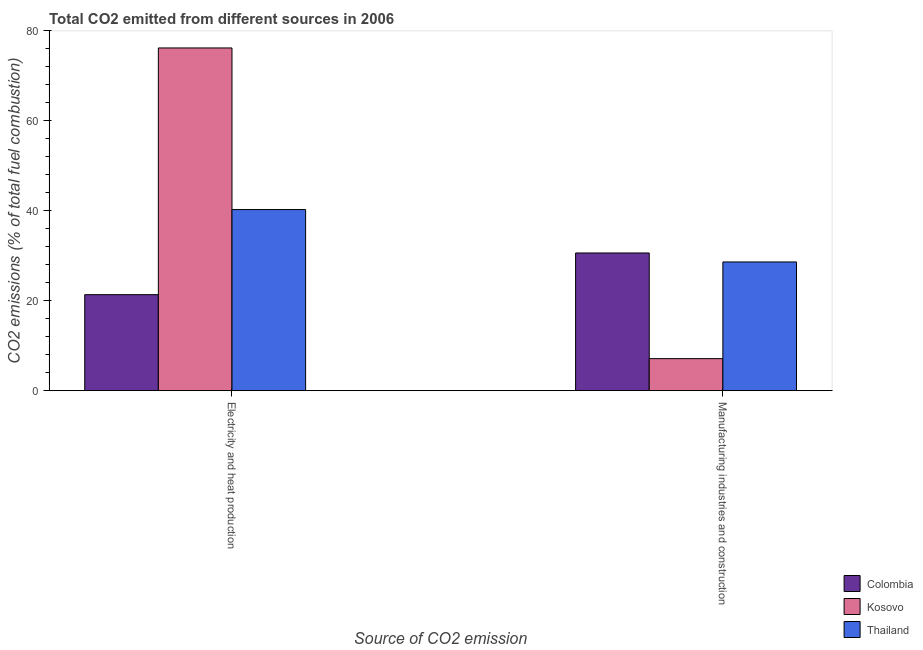How many different coloured bars are there?
Make the answer very short. 3. How many groups of bars are there?
Your answer should be very brief. 2. Are the number of bars per tick equal to the number of legend labels?
Make the answer very short. Yes. How many bars are there on the 2nd tick from the left?
Your answer should be compact. 3. How many bars are there on the 1st tick from the right?
Give a very brief answer. 3. What is the label of the 1st group of bars from the left?
Make the answer very short. Electricity and heat production. What is the co2 emissions due to manufacturing industries in Kosovo?
Your answer should be very brief. 7.12. Across all countries, what is the maximum co2 emissions due to manufacturing industries?
Offer a very short reply. 30.62. Across all countries, what is the minimum co2 emissions due to electricity and heat production?
Provide a succinct answer. 21.35. In which country was the co2 emissions due to electricity and heat production minimum?
Your answer should be compact. Colombia. What is the total co2 emissions due to manufacturing industries in the graph?
Make the answer very short. 66.35. What is the difference between the co2 emissions due to manufacturing industries in Colombia and that in Thailand?
Give a very brief answer. 2. What is the difference between the co2 emissions due to electricity and heat production in Colombia and the co2 emissions due to manufacturing industries in Kosovo?
Your response must be concise. 14.22. What is the average co2 emissions due to manufacturing industries per country?
Provide a short and direct response. 22.12. What is the difference between the co2 emissions due to manufacturing industries and co2 emissions due to electricity and heat production in Colombia?
Your answer should be compact. 9.27. In how many countries, is the co2 emissions due to electricity and heat production greater than 20 %?
Offer a very short reply. 3. What is the ratio of the co2 emissions due to electricity and heat production in Thailand to that in Colombia?
Make the answer very short. 1.89. Is the co2 emissions due to manufacturing industries in Kosovo less than that in Colombia?
Make the answer very short. Yes. What does the 2nd bar from the left in Electricity and heat production represents?
Provide a short and direct response. Kosovo. What does the 3rd bar from the right in Electricity and heat production represents?
Give a very brief answer. Colombia. What is the difference between two consecutive major ticks on the Y-axis?
Your answer should be very brief. 20. Are the values on the major ticks of Y-axis written in scientific E-notation?
Offer a terse response. No. Does the graph contain any zero values?
Offer a very short reply. No. Does the graph contain grids?
Your response must be concise. No. Where does the legend appear in the graph?
Ensure brevity in your answer.  Bottom right. How are the legend labels stacked?
Provide a succinct answer. Vertical. What is the title of the graph?
Give a very brief answer. Total CO2 emitted from different sources in 2006. Does "Botswana" appear as one of the legend labels in the graph?
Give a very brief answer. No. What is the label or title of the X-axis?
Your response must be concise. Source of CO2 emission. What is the label or title of the Y-axis?
Provide a succinct answer. CO2 emissions (% of total fuel combustion). What is the CO2 emissions (% of total fuel combustion) of Colombia in Electricity and heat production?
Your answer should be compact. 21.35. What is the CO2 emissions (% of total fuel combustion) in Kosovo in Electricity and heat production?
Your response must be concise. 76.21. What is the CO2 emissions (% of total fuel combustion) in Thailand in Electricity and heat production?
Ensure brevity in your answer.  40.28. What is the CO2 emissions (% of total fuel combustion) of Colombia in Manufacturing industries and construction?
Provide a short and direct response. 30.62. What is the CO2 emissions (% of total fuel combustion) of Kosovo in Manufacturing industries and construction?
Provide a succinct answer. 7.12. What is the CO2 emissions (% of total fuel combustion) of Thailand in Manufacturing industries and construction?
Make the answer very short. 28.62. Across all Source of CO2 emission, what is the maximum CO2 emissions (% of total fuel combustion) in Colombia?
Offer a terse response. 30.62. Across all Source of CO2 emission, what is the maximum CO2 emissions (% of total fuel combustion) of Kosovo?
Make the answer very short. 76.21. Across all Source of CO2 emission, what is the maximum CO2 emissions (% of total fuel combustion) of Thailand?
Provide a succinct answer. 40.28. Across all Source of CO2 emission, what is the minimum CO2 emissions (% of total fuel combustion) in Colombia?
Make the answer very short. 21.35. Across all Source of CO2 emission, what is the minimum CO2 emissions (% of total fuel combustion) in Kosovo?
Offer a very short reply. 7.12. Across all Source of CO2 emission, what is the minimum CO2 emissions (% of total fuel combustion) of Thailand?
Make the answer very short. 28.62. What is the total CO2 emissions (% of total fuel combustion) of Colombia in the graph?
Provide a short and direct response. 51.96. What is the total CO2 emissions (% of total fuel combustion) of Kosovo in the graph?
Your response must be concise. 83.33. What is the total CO2 emissions (% of total fuel combustion) in Thailand in the graph?
Keep it short and to the point. 68.89. What is the difference between the CO2 emissions (% of total fuel combustion) in Colombia in Electricity and heat production and that in Manufacturing industries and construction?
Provide a short and direct response. -9.27. What is the difference between the CO2 emissions (% of total fuel combustion) of Kosovo in Electricity and heat production and that in Manufacturing industries and construction?
Make the answer very short. 69.09. What is the difference between the CO2 emissions (% of total fuel combustion) of Thailand in Electricity and heat production and that in Manufacturing industries and construction?
Provide a succinct answer. 11.66. What is the difference between the CO2 emissions (% of total fuel combustion) in Colombia in Electricity and heat production and the CO2 emissions (% of total fuel combustion) in Kosovo in Manufacturing industries and construction?
Your response must be concise. 14.22. What is the difference between the CO2 emissions (% of total fuel combustion) in Colombia in Electricity and heat production and the CO2 emissions (% of total fuel combustion) in Thailand in Manufacturing industries and construction?
Offer a very short reply. -7.27. What is the difference between the CO2 emissions (% of total fuel combustion) of Kosovo in Electricity and heat production and the CO2 emissions (% of total fuel combustion) of Thailand in Manufacturing industries and construction?
Provide a short and direct response. 47.59. What is the average CO2 emissions (% of total fuel combustion) in Colombia per Source of CO2 emission?
Your answer should be compact. 25.98. What is the average CO2 emissions (% of total fuel combustion) in Kosovo per Source of CO2 emission?
Your answer should be compact. 41.67. What is the average CO2 emissions (% of total fuel combustion) in Thailand per Source of CO2 emission?
Give a very brief answer. 34.45. What is the difference between the CO2 emissions (% of total fuel combustion) of Colombia and CO2 emissions (% of total fuel combustion) of Kosovo in Electricity and heat production?
Provide a succinct answer. -54.87. What is the difference between the CO2 emissions (% of total fuel combustion) in Colombia and CO2 emissions (% of total fuel combustion) in Thailand in Electricity and heat production?
Your response must be concise. -18.93. What is the difference between the CO2 emissions (% of total fuel combustion) of Kosovo and CO2 emissions (% of total fuel combustion) of Thailand in Electricity and heat production?
Keep it short and to the point. 35.94. What is the difference between the CO2 emissions (% of total fuel combustion) of Colombia and CO2 emissions (% of total fuel combustion) of Kosovo in Manufacturing industries and construction?
Make the answer very short. 23.49. What is the difference between the CO2 emissions (% of total fuel combustion) in Colombia and CO2 emissions (% of total fuel combustion) in Thailand in Manufacturing industries and construction?
Make the answer very short. 2. What is the difference between the CO2 emissions (% of total fuel combustion) of Kosovo and CO2 emissions (% of total fuel combustion) of Thailand in Manufacturing industries and construction?
Offer a terse response. -21.5. What is the ratio of the CO2 emissions (% of total fuel combustion) of Colombia in Electricity and heat production to that in Manufacturing industries and construction?
Your answer should be compact. 0.7. What is the ratio of the CO2 emissions (% of total fuel combustion) in Kosovo in Electricity and heat production to that in Manufacturing industries and construction?
Give a very brief answer. 10.7. What is the ratio of the CO2 emissions (% of total fuel combustion) of Thailand in Electricity and heat production to that in Manufacturing industries and construction?
Provide a short and direct response. 1.41. What is the difference between the highest and the second highest CO2 emissions (% of total fuel combustion) in Colombia?
Provide a succinct answer. 9.27. What is the difference between the highest and the second highest CO2 emissions (% of total fuel combustion) in Kosovo?
Give a very brief answer. 69.09. What is the difference between the highest and the second highest CO2 emissions (% of total fuel combustion) in Thailand?
Provide a short and direct response. 11.66. What is the difference between the highest and the lowest CO2 emissions (% of total fuel combustion) of Colombia?
Your answer should be compact. 9.27. What is the difference between the highest and the lowest CO2 emissions (% of total fuel combustion) in Kosovo?
Offer a very short reply. 69.09. What is the difference between the highest and the lowest CO2 emissions (% of total fuel combustion) of Thailand?
Your answer should be compact. 11.66. 